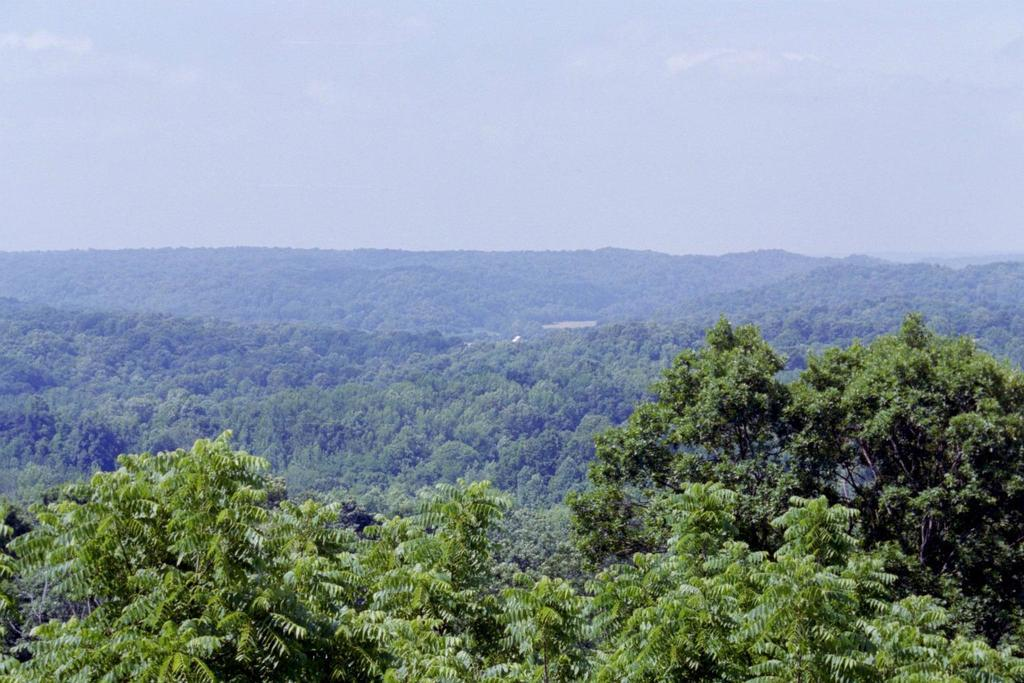What type of natural features can be seen in the image? There are trees and mountains in the image. What is visible at the top of the image? The sky is visible at the top of the image. Can you describe the setting of the image? The image may have been taken in a forest, given the presence of trees. How many stamps are attached to the trees in the image? There are no stamps present in the image; it features trees and mountains. What type of hen can be seen in the image? There is no hen present in the image. 